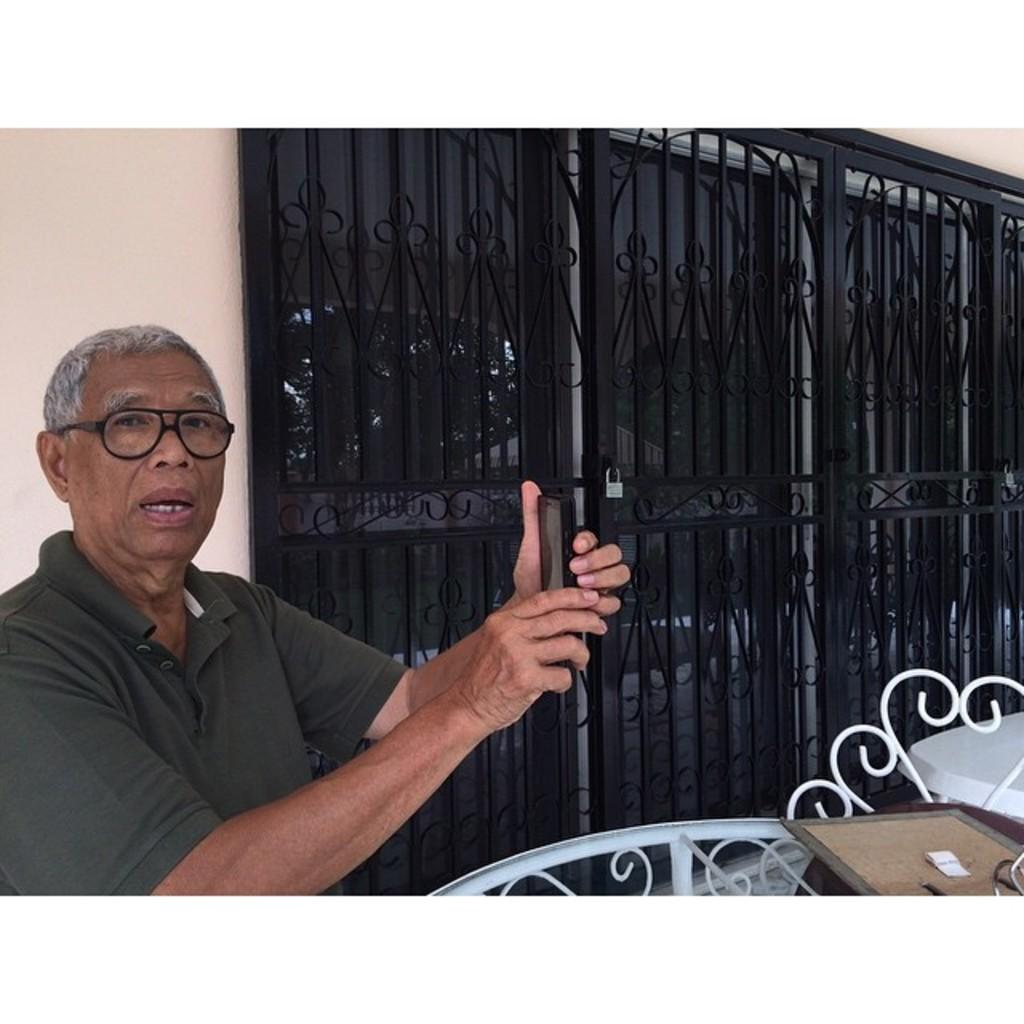Who is present in the image? There is a man in the image. What is the man holding in his hand? The man is holding a mobile in his hand. Can you describe the man's appearance? The man is wearing spectacles. What type of furniture is in the image? There is a table in the image. What is the structure of the door visible in the image? There is a metal grill on a glass door in the image. What security feature is visible in the image? There is a lock visible in the image. What type of vase is on the table in the image? There is no vase present on the table in the image. 